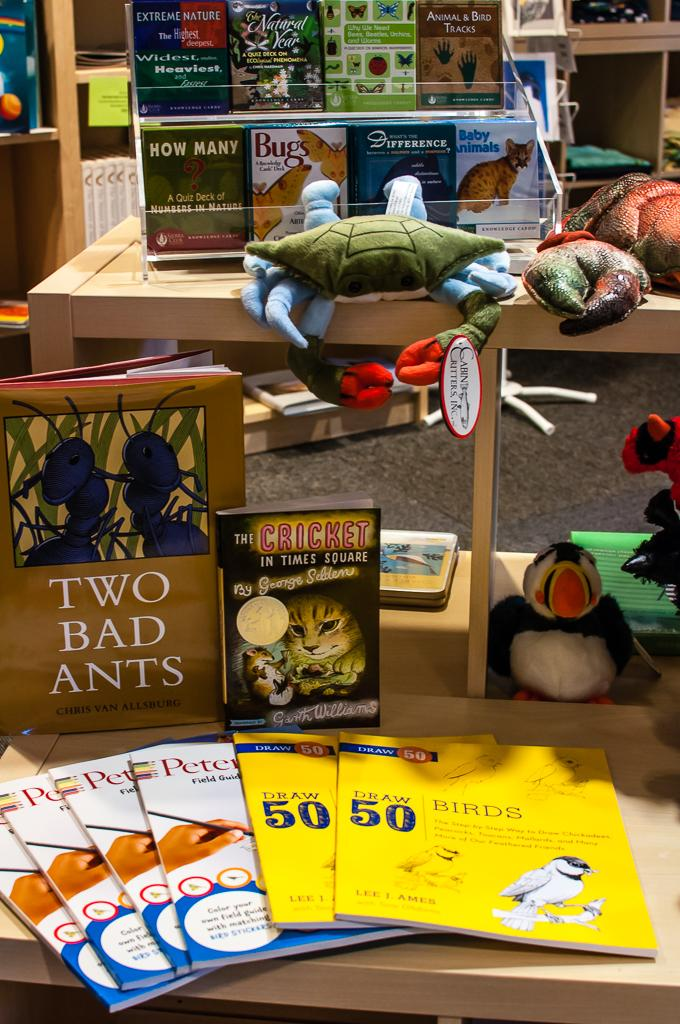Provide a one-sentence caption for the provided image. Books about animals are displayed on the shelf. 